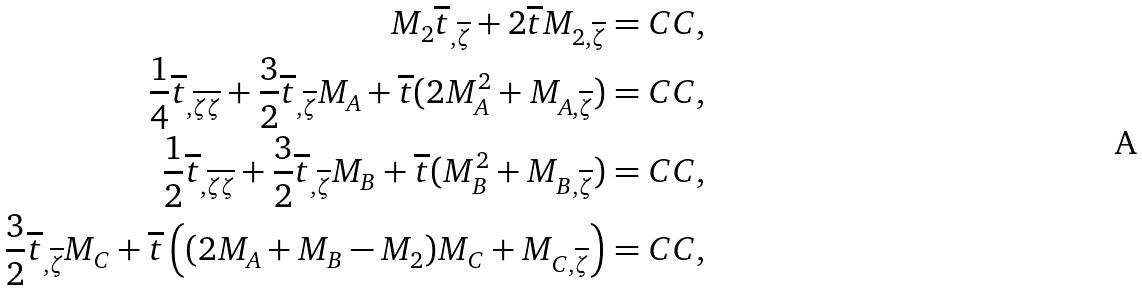Convert formula to latex. <formula><loc_0><loc_0><loc_500><loc_500>M _ { 2 } \overline { t } _ { , \overline { \zeta } } + 2 \overline { t } M _ { 2 , \overline { \zeta } } = C C , \\ \frac { 1 } { 4 } \overline { t } _ { , \overline { \zeta \zeta } } + \frac { 3 } { 2 } \overline { t } _ { , \overline { \zeta } } M _ { A } + \overline { t } ( 2 M _ { A } ^ { 2 } + M _ { A , \overline { \zeta } } ) = C C , \\ \frac { 1 } { 2 } \overline { t } _ { , \overline { \zeta \zeta } } + \frac { 3 } { 2 } \overline { t } _ { , \overline { \zeta } } M _ { B } + \overline { t } ( M _ { B } ^ { 2 } + M _ { B , \overline { \zeta } } ) = C C , \\ \frac { 3 } { 2 } \overline { t } _ { , \overline { \zeta } } M _ { C } + \overline { t } \left ( ( 2 M _ { A } + M _ { B } - M _ { 2 } ) M _ { C } + M _ { C , \overline { \zeta } } \right ) = C C ,</formula> 